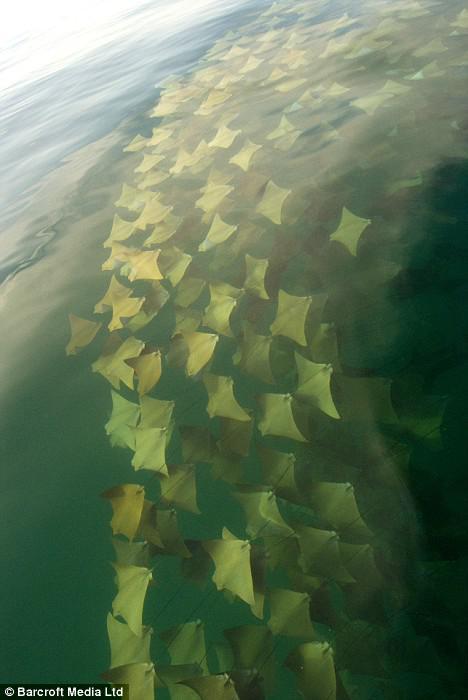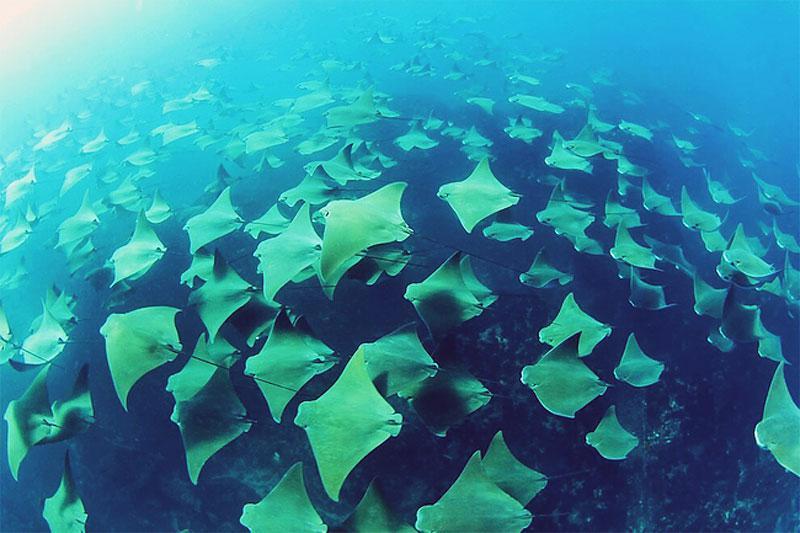The first image is the image on the left, the second image is the image on the right. Examine the images to the left and right. Is the description "An image shows a mass of stingrays in vivid blue water." accurate? Answer yes or no. Yes. The first image is the image on the left, the second image is the image on the right. Analyze the images presented: Is the assertion "Animals are in blue water in the image on the right." valid? Answer yes or no. Yes. 